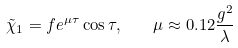<formula> <loc_0><loc_0><loc_500><loc_500>\tilde { \chi } _ { 1 } = f e ^ { \mu \tau } \cos \tau , \quad \mu \approx 0 . 1 2 \frac { g ^ { 2 } } { \lambda }</formula> 